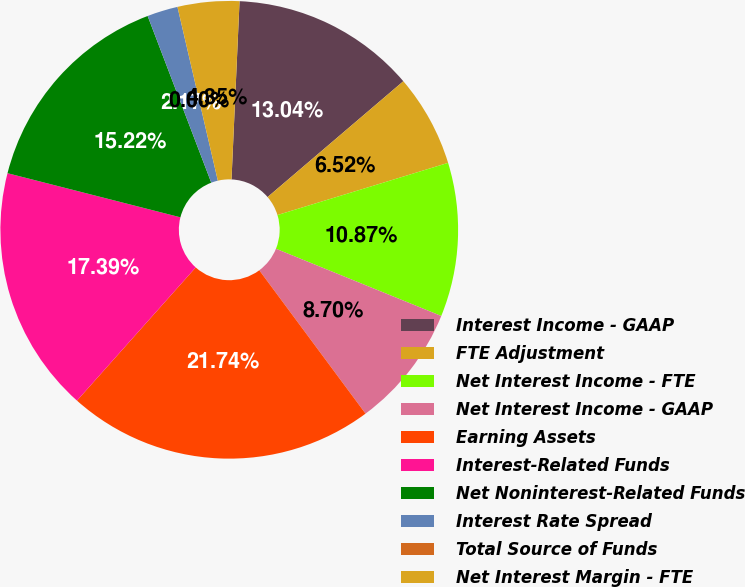Convert chart to OTSL. <chart><loc_0><loc_0><loc_500><loc_500><pie_chart><fcel>Interest Income - GAAP<fcel>FTE Adjustment<fcel>Net Interest Income - FTE<fcel>Net Interest Income - GAAP<fcel>Earning Assets<fcel>Interest-Related Funds<fcel>Net Noninterest-Related Funds<fcel>Interest Rate Spread<fcel>Total Source of Funds<fcel>Net Interest Margin - FTE<nl><fcel>13.04%<fcel>6.52%<fcel>10.87%<fcel>8.7%<fcel>21.74%<fcel>17.39%<fcel>15.22%<fcel>2.17%<fcel>0.0%<fcel>4.35%<nl></chart> 